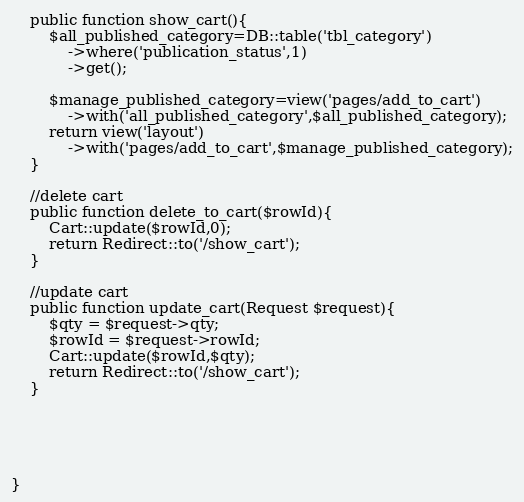Convert code to text. <code><loc_0><loc_0><loc_500><loc_500><_PHP_>
    public function show_cart(){
        $all_published_category=DB::table('tbl_category')
            ->where('publication_status',1)
            ->get();

        $manage_published_category=view('pages/add_to_cart')
            ->with('all_published_category',$all_published_category);
        return view('layout')
            ->with('pages/add_to_cart',$manage_published_category);
    }

    //delete cart
    public function delete_to_cart($rowId){
        Cart::update($rowId,0);
        return Redirect::to('/show_cart');
    }

    //update cart
    public function update_cart(Request $request){
        $qty = $request->qty;
        $rowId = $request->rowId;
        Cart::update($rowId,$qty);
        return Redirect::to('/show_cart');
    }





}
</code> 